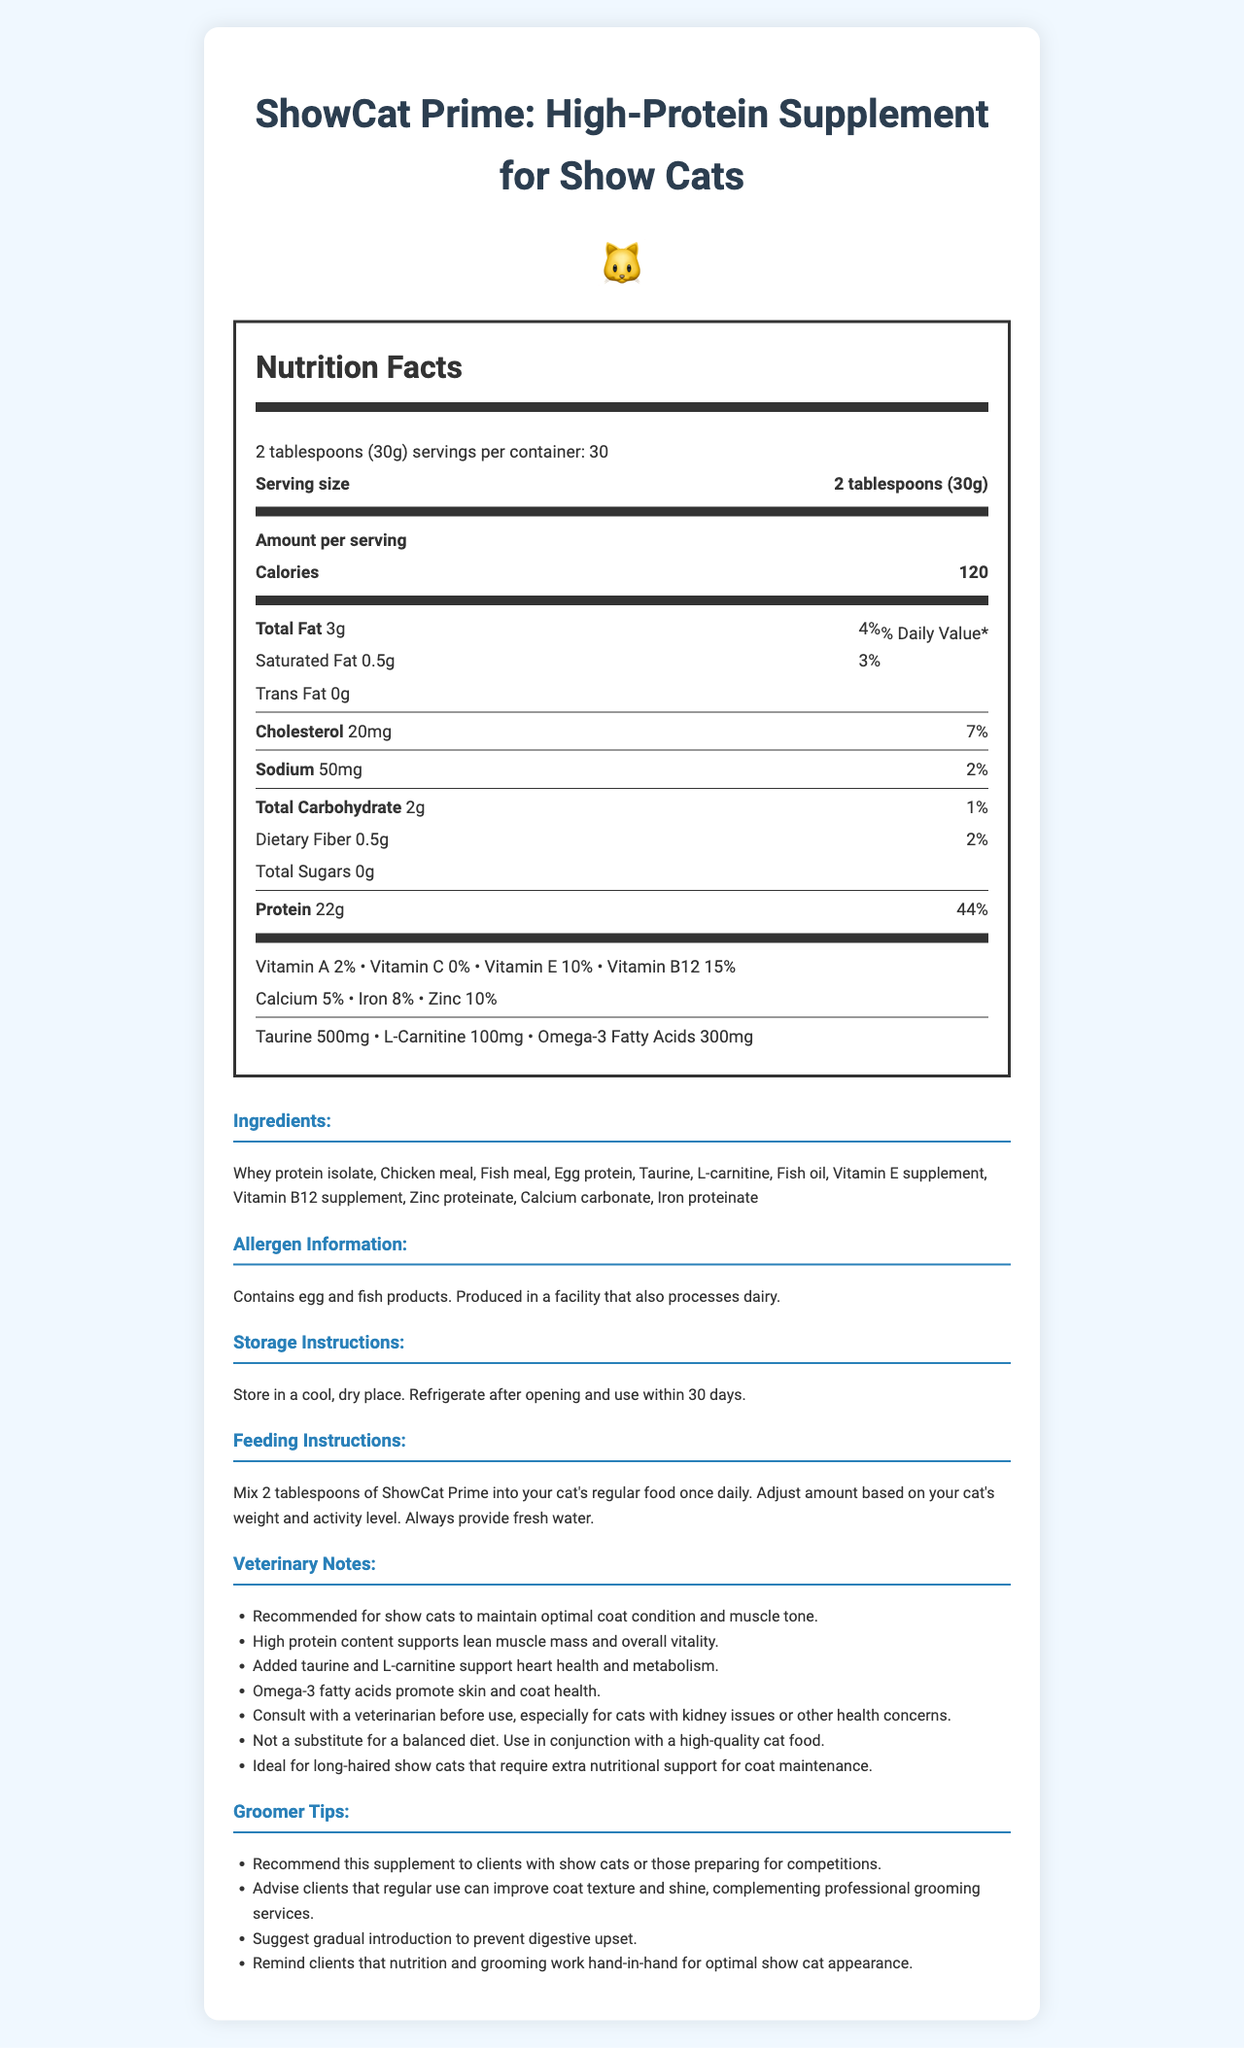what is the serving size for ShowCat Prime? The serving size is mentioned in the Nutrition Facts section at the beginning.
Answer: 2 tablespoons (30g) how many servings per container are there? The number of servings per container is listed directly after the serving size information.
Answer: 30 what is the calorie count per serving? The amount of calories per serving is listed immediately after the serving size and servings per container information.
Answer: 120 calories list the main ingredients in ShowCat Prime. The ingredients section lists all the main components, starting with Whey protein isolate.
Answer: Whey protein isolate, Chicken meal, Fish meal, Egg protein, Taurine what is the amount of protein per serving? The amount of protein per serving is listed in the Nutrition Facts section.
Answer: 22g what is the recommended storage instruction? The storage instructions section provides this information clearly.
Answer: Store in a cool, dry place. Refrigerate after opening and use within 30 days. how much saturated fat does ShowCat Prime contain per serving? The amount of saturated fat per serving is listed in the Nutrition Facts section.
Answer: 0.5g what is the daily value percentage of vitamin B12 per serving? The daily value percentage of vitamin B12 is mentioned alongside the other vitamins in the Nutrition Facts section.
Answer: 15% how much taurine is added in ShowCat Prime? The amount of Taurine added is explicitly stated in the Nutrition Facts section.
Answer: 500mg what is the daily value percentage of iron in ShowCat Prime? The daily value percentage of iron is listed in the Nutrition Facts section.
Answer: 8% which of the following is NOT an ingredient in ShowCat Prime? A. Whey protein isolate B. Soy protein C. Fish meal D. Vitamin E supplement Soy protein is not listed among the ingredients; the document lists Whey protein isolate, Chicken meal, Fish meal, Egg protein, Vitamin E supplement.
Answer: B. Soy protein how often should you mix ShowCat Prime into your cat's regular food? A. Twice daily B. Once daily C. Weekly D. Monthly The feeding instructions recommend mixing 2 tablespoons of ShowCat Prime into your cat's regular food once daily.
Answer: B. Once daily is ShowCat Prime suitable for all cats without any prior consultation? The supplementation advises consulting with a veterinarian, especially for cats with kidney issues or other health concerns.
Answer: No describe the main purpose of ShowCat Prime. The product description and veterinary notes highlight these specific purposes.
Answer: ShowCat Prime aims to support show cats by providing high-protein nutrition to maintain optimal coat condition and muscle tone, along with supporting overall vitality, heart health, metabolism, and skin and coat health. can we determine the specific proportion of chicken meal in ShowCat Prime? The document lists chicken meal as an ingredient but does not specify the proportion.
Answer: Cannot be determined what allergen information is provided for ShowCat Prime? The allergen information section clearly states the allergens and potential cross-contamination risks.
Answer: Contains egg and fish products. Produced in a facility that also processes dairy. 